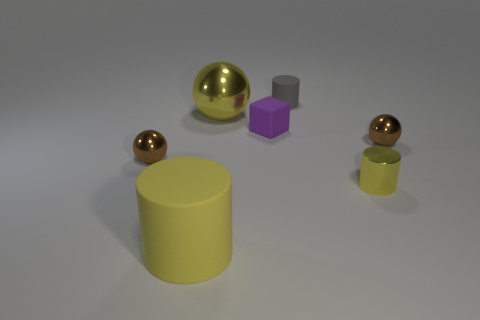There is a big sphere; is its color the same as the big thing that is in front of the small purple matte block?
Make the answer very short. Yes. What is the shape of the other matte thing that is the same size as the purple rubber object?
Provide a succinct answer. Cylinder. Are there any small matte things that have the same shape as the large matte object?
Your answer should be compact. Yes. Are the gray object and the brown sphere that is to the right of the purple object made of the same material?
Make the answer very short. No. What material is the small brown thing left of the yellow thing on the right side of the gray rubber cylinder?
Your answer should be very brief. Metal. Is the number of small brown metal spheres that are to the left of the small purple thing greater than the number of large metal spheres?
Make the answer very short. No. Are any small matte objects visible?
Your answer should be compact. Yes. The tiny matte object in front of the small gray object is what color?
Provide a succinct answer. Purple. What is the material of the yellow cylinder that is the same size as the gray thing?
Your response must be concise. Metal. What number of other things are there of the same material as the big ball
Give a very brief answer. 3. 